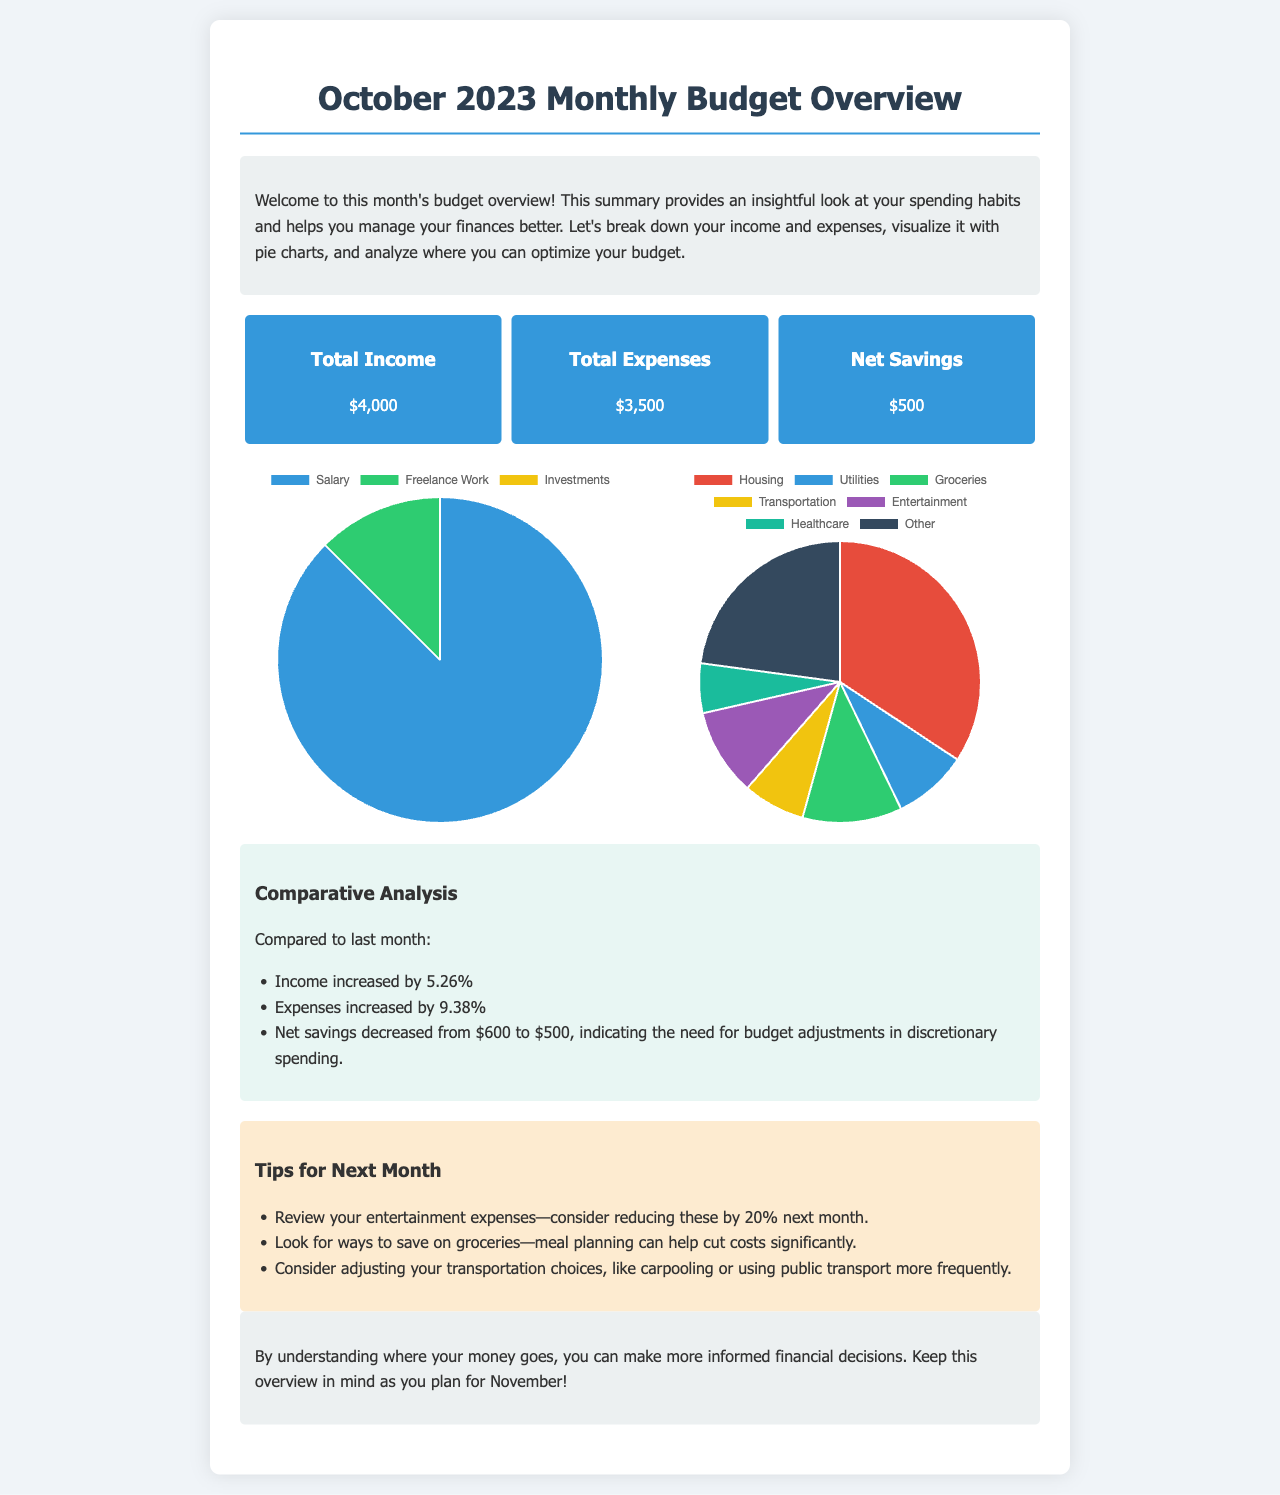What is the total income for October 2023? The total income is specified as $4,000 in the document under total income.
Answer: $4,000 What was the total expenses for October 2023? The total expenses are stated as $3,500 in the document under total expenses.
Answer: $3,500 What is the net savings for the month? The net savings are calculated and given as $500 in the document under net savings.
Answer: $500 By what percentage did income increase compared to last month? The document mentions that income increased by 5.26% compared to the previous month.
Answer: 5.26% Which category has the highest expense percentage? The expenses chart indicates that housing constitutes the highest percentage of expenses at 34.29%.
Answer: Housing What is one suggested tip for next month? The document lists several tips, one of which is to reduce entertainment expenses by 20%.
Answer: Reduce entertainment expenses by 20% How many categories are listed under expenses? The expenses pie chart shows a total of seven distinct categories for expenses.
Answer: Seven What type of charts are used to represent income and expenses? The document specifies that pie charts are utilized to represent both income and expenses distributions.
Answer: Pie charts What is the comparison outcome for net savings from last month? The document states that net savings decreased from $600 to $500, indicating a need for adjustments.
Answer: Decreased from $600 to $500 